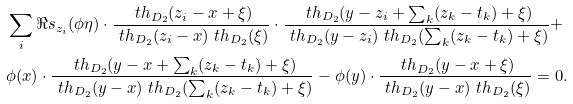Convert formula to latex. <formula><loc_0><loc_0><loc_500><loc_500>& \sum _ { i } \Re s _ { z _ { i } } ( \phi \eta ) \cdot \frac { \ t h _ { D _ { 2 } } ( z _ { i } - x + \xi ) } { \ t h _ { D _ { 2 } } ( z _ { i } - x ) \ t h _ { D _ { 2 } } ( \xi ) } \cdot \frac { \ t h _ { D _ { 2 } } ( y - z _ { i } + \sum _ { k } ( z _ { k } - t _ { k } ) + \xi ) } { \ t h _ { D _ { 2 } } ( y - z _ { i } ) \ t h _ { D _ { 2 } } ( \sum _ { k } ( z _ { k } - t _ { k } ) + \xi ) } + \\ & \phi ( x ) \cdot \frac { \ t h _ { D _ { 2 } } ( y - x + \sum _ { k } ( z _ { k } - t _ { k } ) + \xi ) } { \ t h _ { D _ { 2 } } ( y - x ) \ t h _ { D _ { 2 } } ( \sum _ { k } ( z _ { k } - t _ { k } ) + \xi ) } - \phi ( y ) \cdot \frac { \ t h _ { D _ { 2 } } ( y - x + \xi ) } { \ t h _ { D _ { 2 } } ( y - x ) \ t h _ { D _ { 2 } } ( \xi ) } = 0 .</formula> 